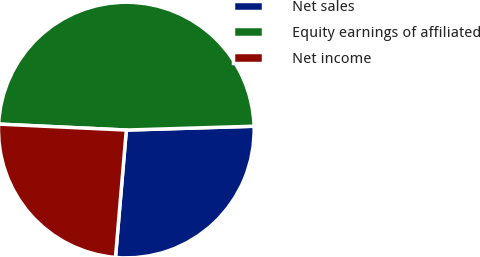Convert chart to OTSL. <chart><loc_0><loc_0><loc_500><loc_500><pie_chart><fcel>Net sales<fcel>Equity earnings of affiliated<fcel>Net income<nl><fcel>26.83%<fcel>48.78%<fcel>24.39%<nl></chart> 